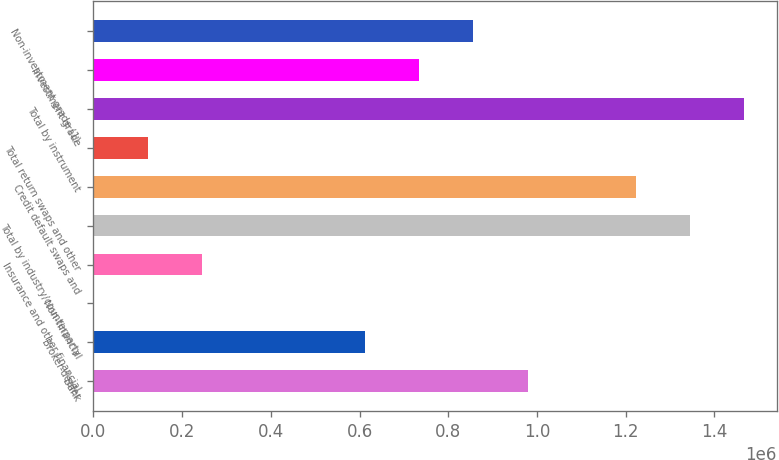Convert chart to OTSL. <chart><loc_0><loc_0><loc_500><loc_500><bar_chart><fcel>Bank<fcel>Broker-dealer<fcel>Non-financial<fcel>Insurance and other financial<fcel>Total by industry/counterparty<fcel>Credit default swaps and<fcel>Total return swaps and other<fcel>Total by instrument<fcel>Investment grade<fcel>Non-investment grade (1)<nl><fcel>978785<fcel>612290<fcel>1463<fcel>245794<fcel>1.34528e+06<fcel>1.22312e+06<fcel>123628<fcel>1.46745e+06<fcel>734455<fcel>856620<nl></chart> 